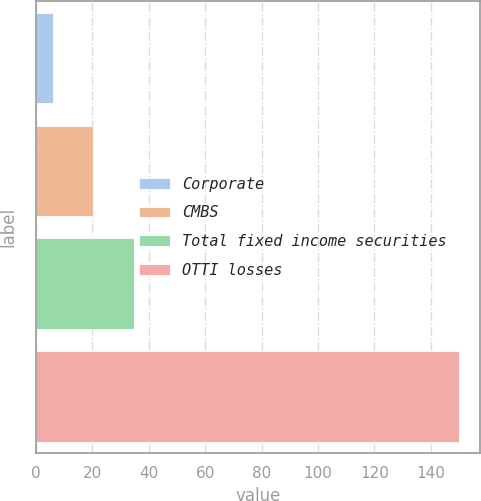Convert chart to OTSL. <chart><loc_0><loc_0><loc_500><loc_500><bar_chart><fcel>Corporate<fcel>CMBS<fcel>Total fixed income securities<fcel>OTTI losses<nl><fcel>6<fcel>20.4<fcel>34.8<fcel>150<nl></chart> 